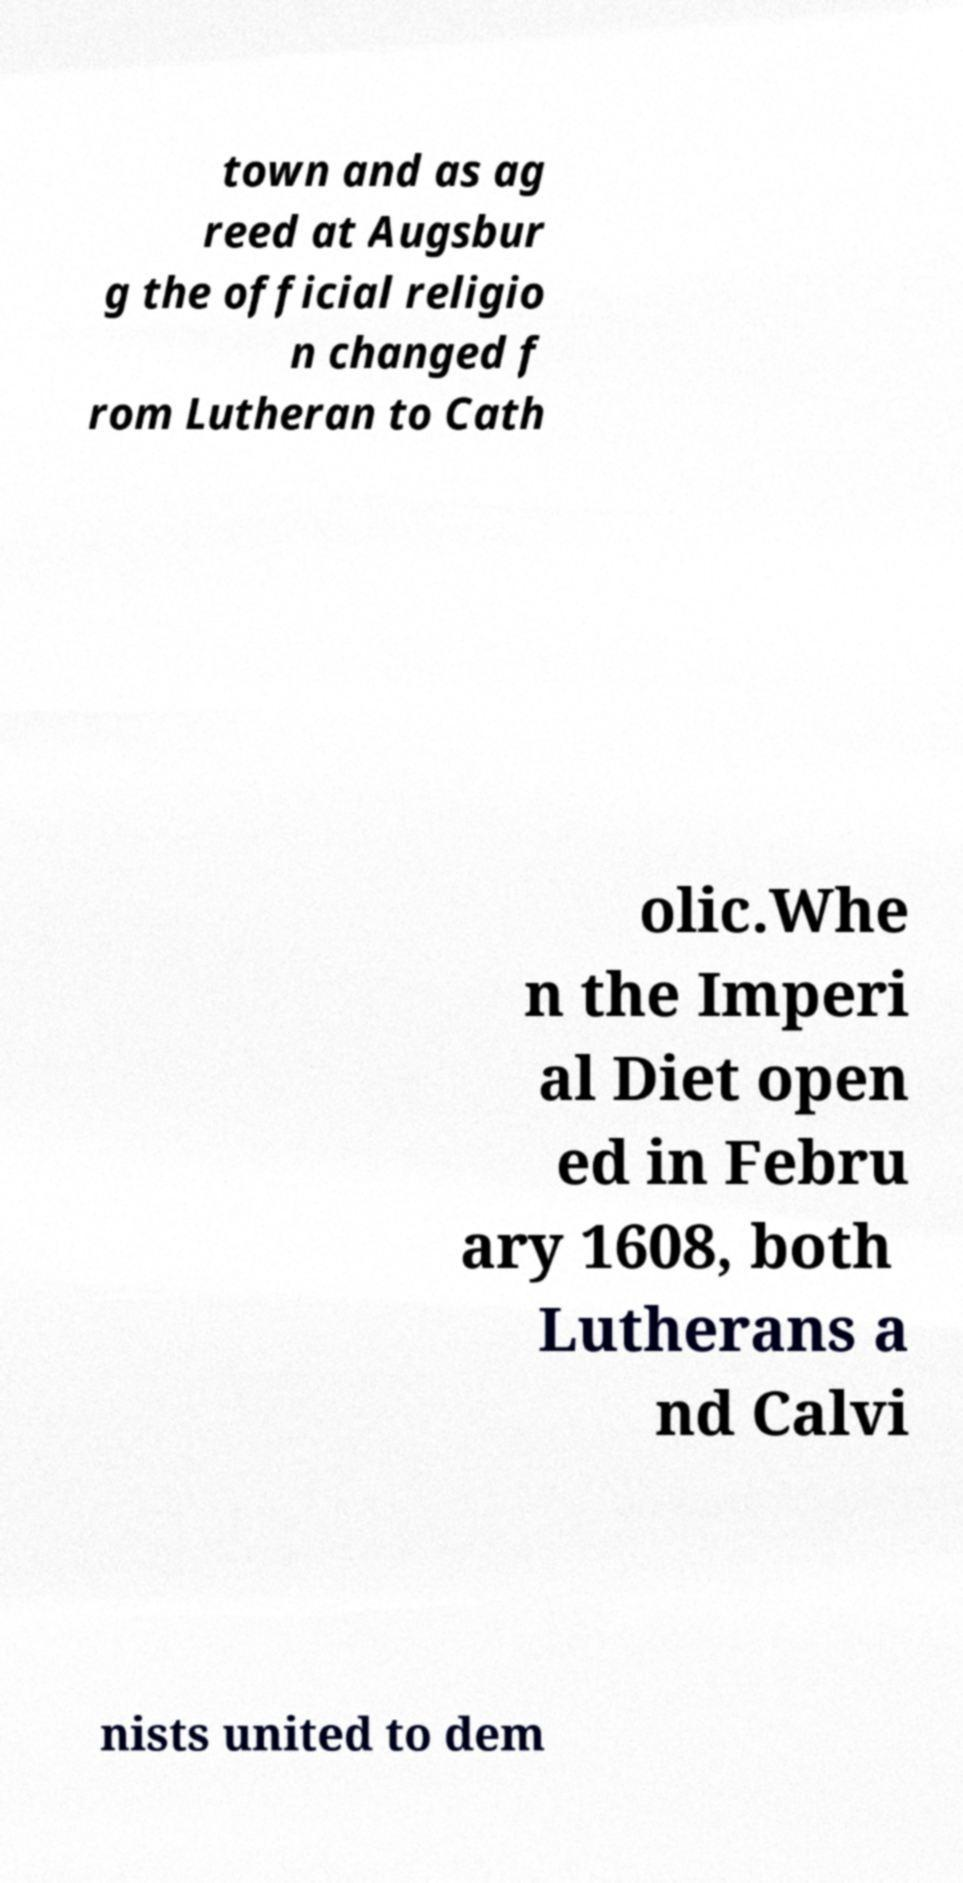Could you assist in decoding the text presented in this image and type it out clearly? town and as ag reed at Augsbur g the official religio n changed f rom Lutheran to Cath olic.Whe n the Imperi al Diet open ed in Febru ary 1608, both Lutherans a nd Calvi nists united to dem 